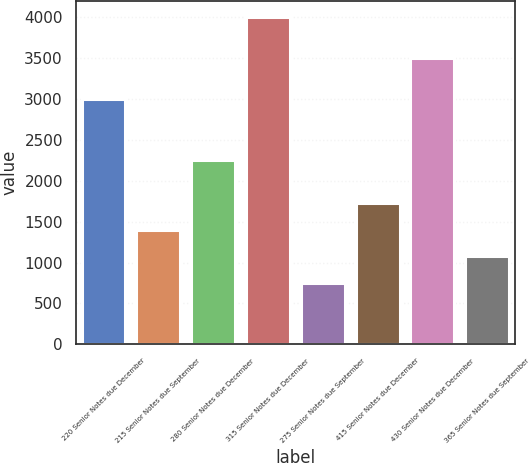<chart> <loc_0><loc_0><loc_500><loc_500><bar_chart><fcel>220 Senior Notes due December<fcel>215 Senior Notes due September<fcel>280 Senior Notes due December<fcel>315 Senior Notes due December<fcel>275 Senior Notes due September<fcel>415 Senior Notes due December<fcel>430 Senior Notes due December<fcel>365 Senior Notes due September<nl><fcel>3000<fcel>1400<fcel>2250<fcel>4000<fcel>750<fcel>1725<fcel>3500<fcel>1075<nl></chart> 